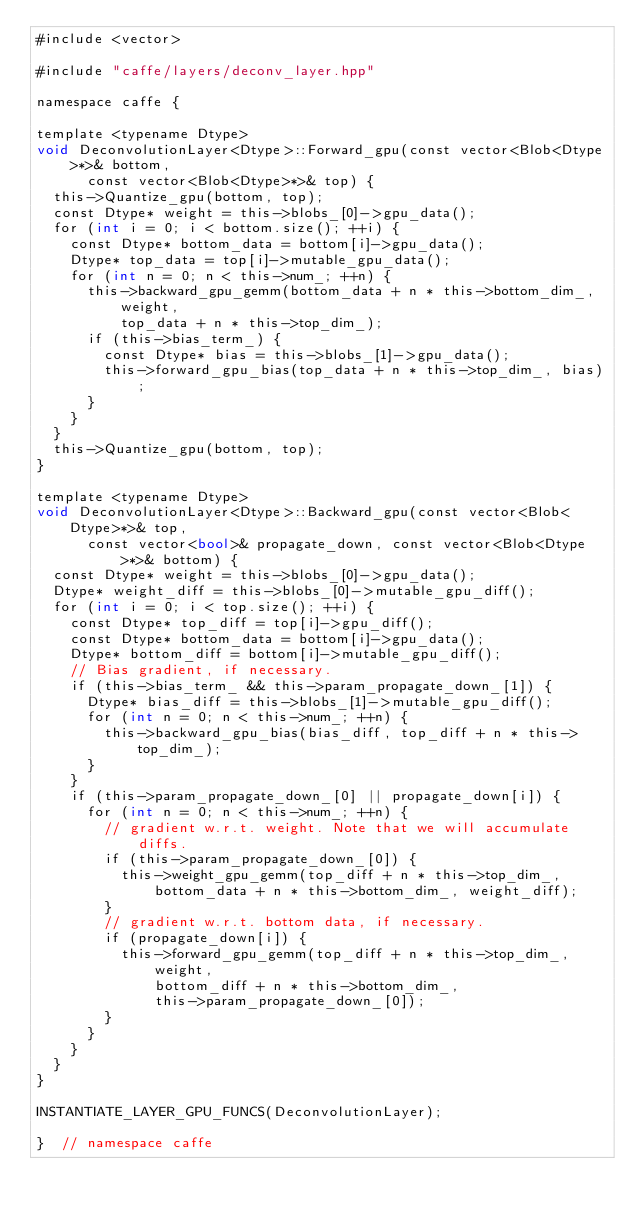Convert code to text. <code><loc_0><loc_0><loc_500><loc_500><_Cuda_>#include <vector>

#include "caffe/layers/deconv_layer.hpp"

namespace caffe {

template <typename Dtype>
void DeconvolutionLayer<Dtype>::Forward_gpu(const vector<Blob<Dtype>*>& bottom,
      const vector<Blob<Dtype>*>& top) {
  this->Quantize_gpu(bottom, top);
  const Dtype* weight = this->blobs_[0]->gpu_data();
  for (int i = 0; i < bottom.size(); ++i) {
    const Dtype* bottom_data = bottom[i]->gpu_data();
    Dtype* top_data = top[i]->mutable_gpu_data();
    for (int n = 0; n < this->num_; ++n) {
      this->backward_gpu_gemm(bottom_data + n * this->bottom_dim_, weight,
          top_data + n * this->top_dim_);
      if (this->bias_term_) {
        const Dtype* bias = this->blobs_[1]->gpu_data();
        this->forward_gpu_bias(top_data + n * this->top_dim_, bias);
      }
    }
  }
  this->Quantize_gpu(bottom, top);
}

template <typename Dtype>
void DeconvolutionLayer<Dtype>::Backward_gpu(const vector<Blob<Dtype>*>& top,
      const vector<bool>& propagate_down, const vector<Blob<Dtype>*>& bottom) {
  const Dtype* weight = this->blobs_[0]->gpu_data();
  Dtype* weight_diff = this->blobs_[0]->mutable_gpu_diff();
  for (int i = 0; i < top.size(); ++i) {
    const Dtype* top_diff = top[i]->gpu_diff();
    const Dtype* bottom_data = bottom[i]->gpu_data();
    Dtype* bottom_diff = bottom[i]->mutable_gpu_diff();
    // Bias gradient, if necessary.
    if (this->bias_term_ && this->param_propagate_down_[1]) {
      Dtype* bias_diff = this->blobs_[1]->mutable_gpu_diff();
      for (int n = 0; n < this->num_; ++n) {
        this->backward_gpu_bias(bias_diff, top_diff + n * this->top_dim_);
      }
    }
    if (this->param_propagate_down_[0] || propagate_down[i]) {
      for (int n = 0; n < this->num_; ++n) {
        // gradient w.r.t. weight. Note that we will accumulate diffs.
        if (this->param_propagate_down_[0]) {
          this->weight_gpu_gemm(top_diff + n * this->top_dim_,
              bottom_data + n * this->bottom_dim_, weight_diff);
        }
        // gradient w.r.t. bottom data, if necessary.
        if (propagate_down[i]) {
          this->forward_gpu_gemm(top_diff + n * this->top_dim_, weight,
              bottom_diff + n * this->bottom_dim_,
              this->param_propagate_down_[0]);
        }
      }
    }
  }
}

INSTANTIATE_LAYER_GPU_FUNCS(DeconvolutionLayer);

}  // namespace caffe
</code> 